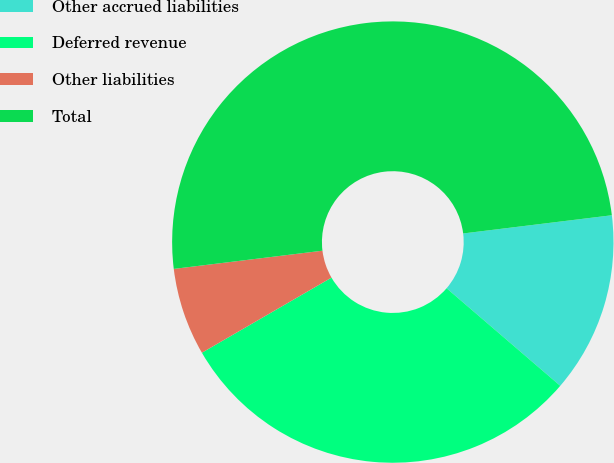Convert chart to OTSL. <chart><loc_0><loc_0><loc_500><loc_500><pie_chart><fcel>Other accrued liabilities<fcel>Deferred revenue<fcel>Other liabilities<fcel>Total<nl><fcel>13.23%<fcel>30.35%<fcel>6.42%<fcel>50.0%<nl></chart> 